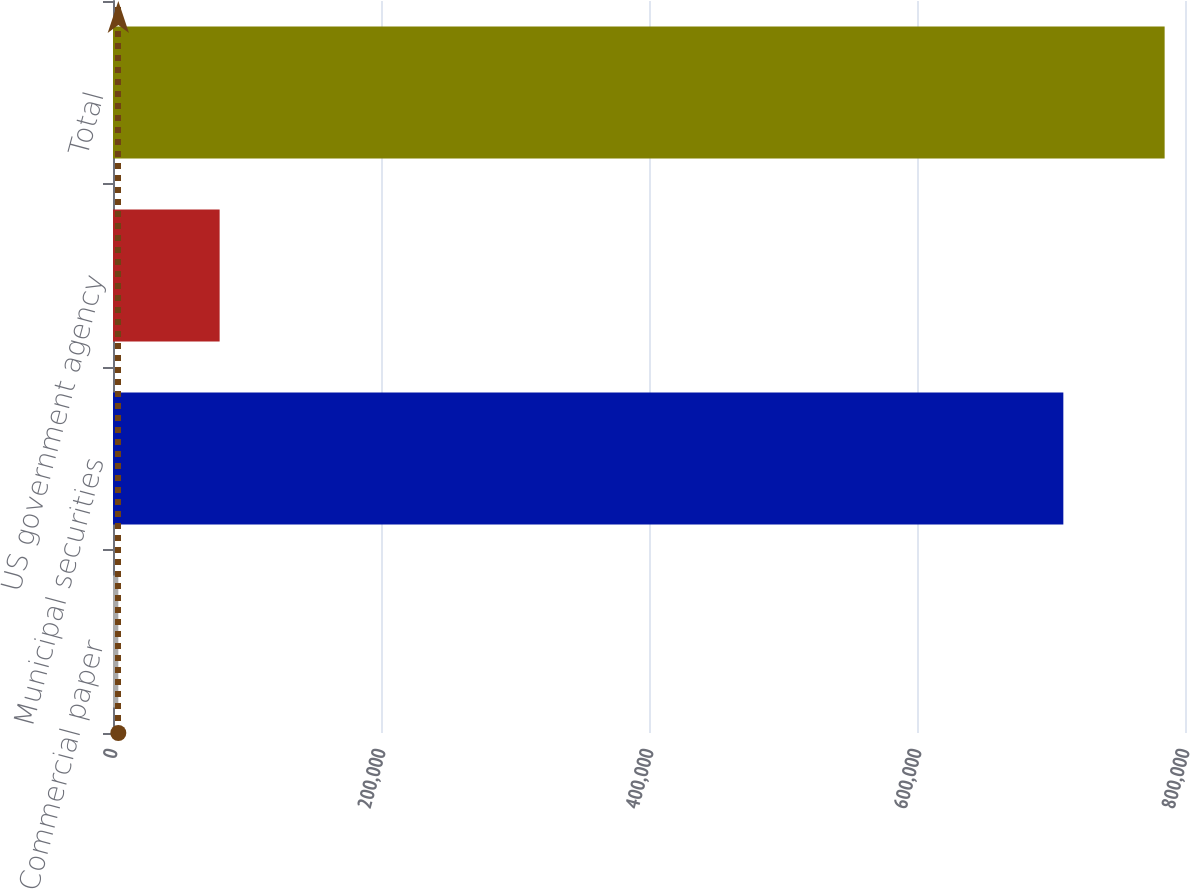Convert chart. <chart><loc_0><loc_0><loc_500><loc_500><bar_chart><fcel>Commercial paper<fcel>Municipal securities<fcel>US government agency<fcel>Total<nl><fcel>3978<fcel>709207<fcel>79576<fcel>784805<nl></chart> 